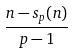Convert formula to latex. <formula><loc_0><loc_0><loc_500><loc_500>\frac { n - s _ { p } ( n ) } { p - 1 }</formula> 